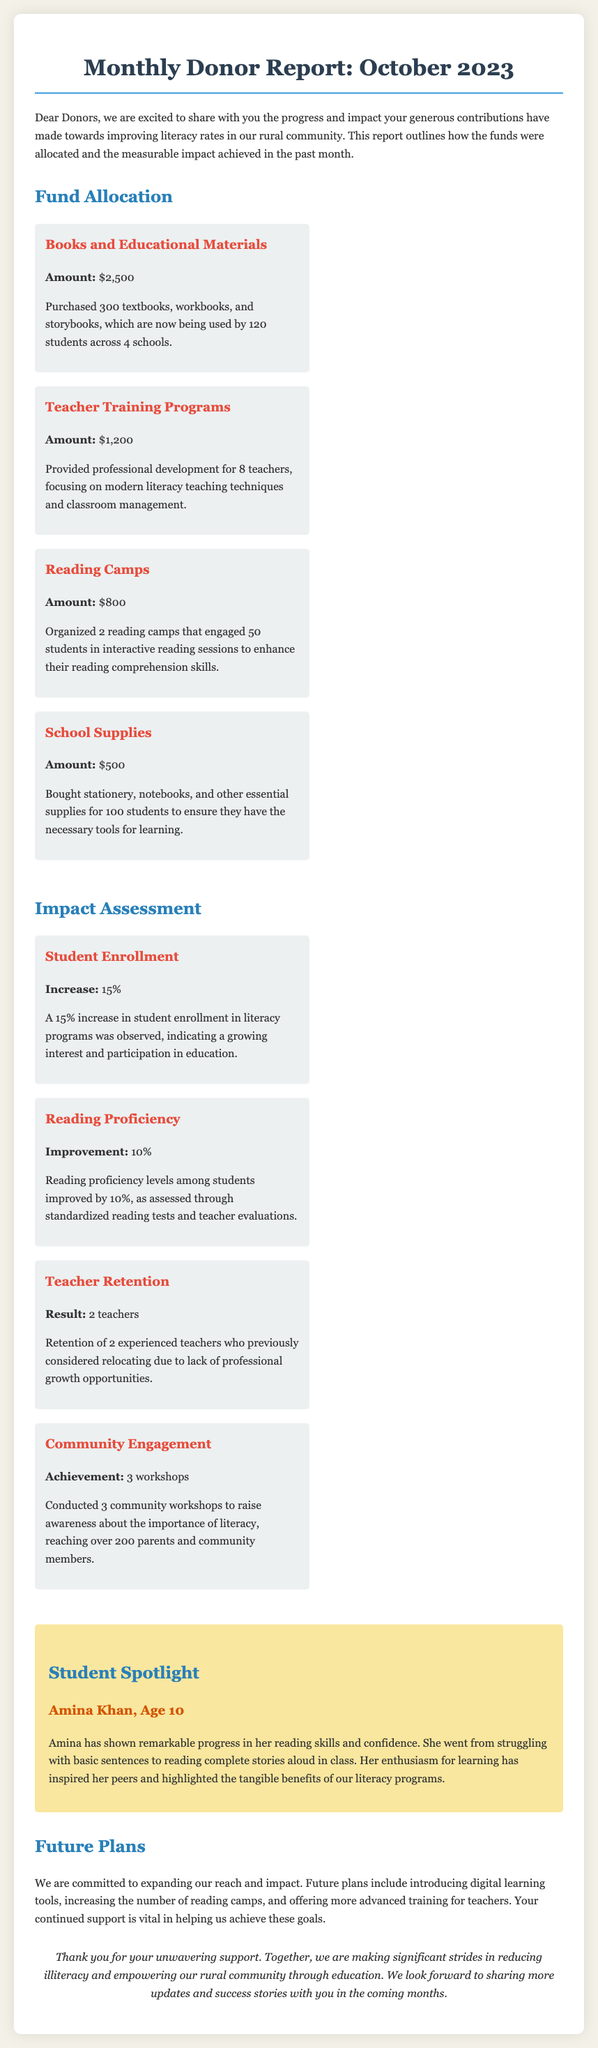What is the total amount allocated for books and educational materials? The report states that the amount allocated for books and educational materials is $2,500.
Answer: $2,500 How many teachers received training programs? It mentions that 8 teachers received training in the teacher training programs section.
Answer: 8 teachers What percentage increase was observed in student enrollment? The document indicates a 15% increase in student enrollment in literacy programs.
Answer: 15% How many reading camps were organized in October 2023? The report specifies that 2 reading camps were organized during this month.
Answer: 2 reading camps What improvement percentage was reported for reading proficiency? The document states that reading proficiency improved by 10% among students.
Answer: 10% What is the name of the student spotlighted in the report? The report highlights Amina Khan as the student whose progress is noted.
Answer: Amina Khan How much was spent on school supplies? The document lists the amount spent on school supplies as $500.
Answer: $500 How many community workshops were conducted? The impact assessment states that 3 community workshops were conducted.
Answer: 3 workshops How many students are reported to be using books and materials? The report mentions that 120 students are now using the purchased textbooks and materials.
Answer: 120 students 